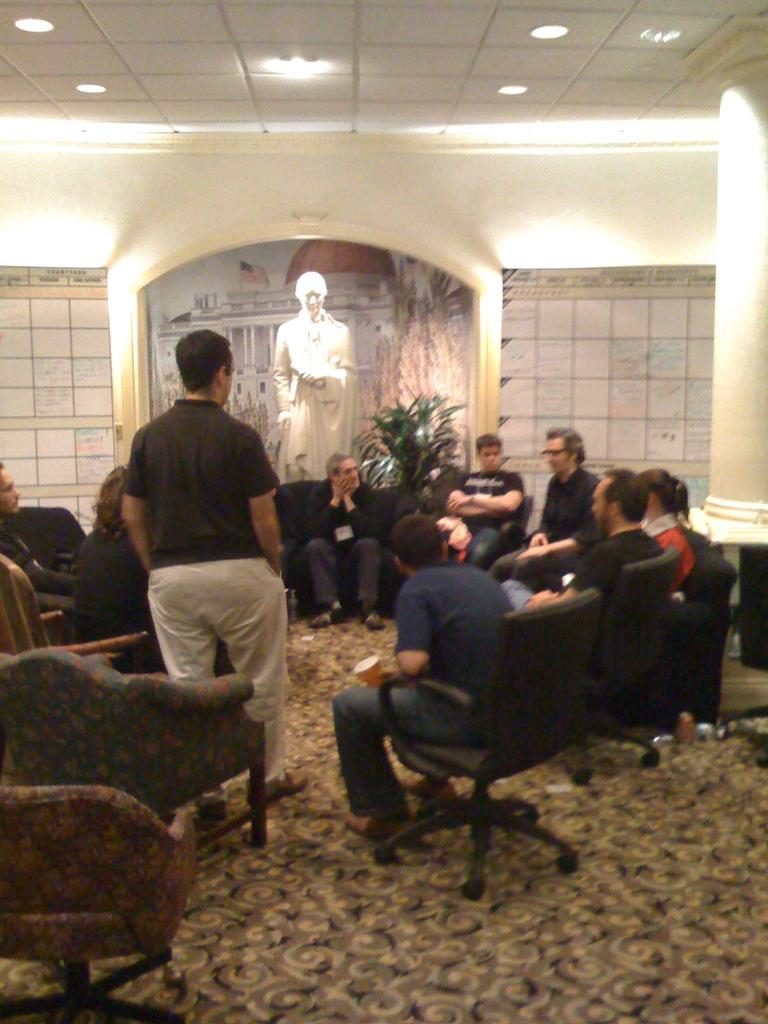What are the people in the image doing? There is a group of people sitting on chairs in the image. What is the man in the image doing? There is a man standing on the floor in the image. What type of vegetation can be seen in the image? There is a plant visible in the image. What type of object can be seen in the image that is not a living organism? There is a statue in the image. What type of structure is visible in the image? There is a wall in the image. What can be seen on the rooftop in the image? There are lights on the rooftop in the image. What type of education is being provided in the image? There is no indication of any educational activity in the image. What type of tool is being used by the people in the image? There is no tool visible in the image. 